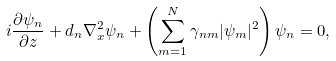<formula> <loc_0><loc_0><loc_500><loc_500>i \frac { \partial \psi _ { n } } { \partial z } + d _ { n } \nabla ^ { 2 } _ { x } \psi _ { n } + \left ( \sum _ { m = 1 } ^ { N } \gamma _ { n m } | \psi _ { m } | ^ { 2 } \right ) \psi _ { n } = 0 ,</formula> 